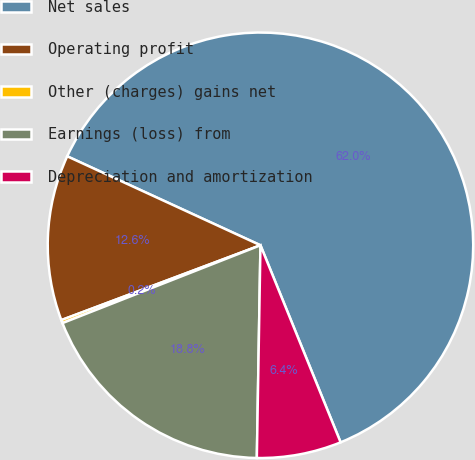<chart> <loc_0><loc_0><loc_500><loc_500><pie_chart><fcel>Net sales<fcel>Operating profit<fcel>Other (charges) gains net<fcel>Earnings (loss) from<fcel>Depreciation and amortization<nl><fcel>61.99%<fcel>12.59%<fcel>0.24%<fcel>18.77%<fcel>6.42%<nl></chart> 